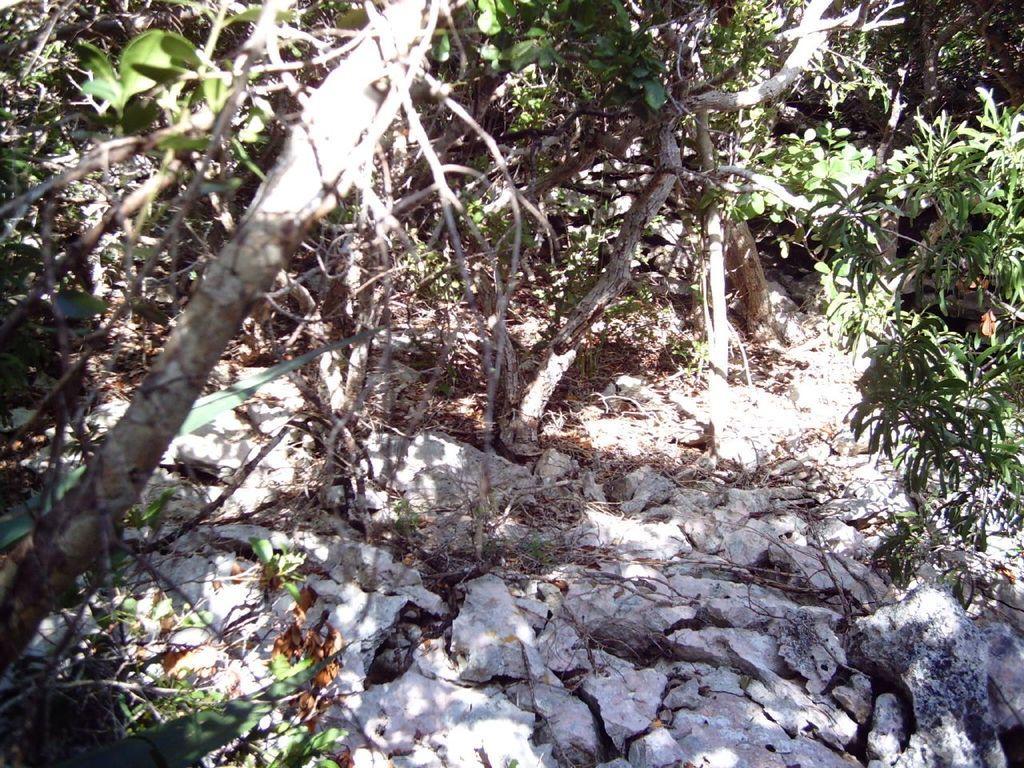Can you describe this image briefly? In the image we can see there are trees and there are rocks on the ground. 